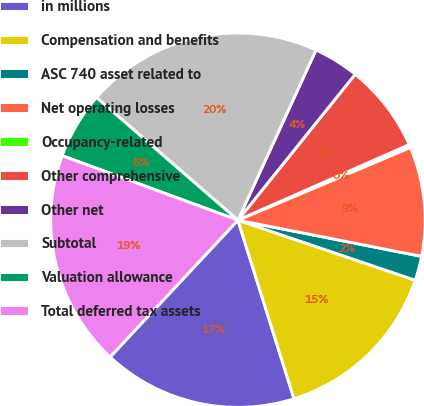Convert chart. <chart><loc_0><loc_0><loc_500><loc_500><pie_chart><fcel>in millions<fcel>Compensation and benefits<fcel>ASC 740 asset related to<fcel>Net operating losses<fcel>Occupancy-related<fcel>Other comprehensive<fcel>Other net<fcel>Subtotal<fcel>Valuation allowance<fcel>Total deferred tax assets<nl><fcel>16.8%<fcel>14.96%<fcel>2.1%<fcel>9.45%<fcel>0.26%<fcel>7.61%<fcel>3.93%<fcel>20.48%<fcel>5.77%<fcel>18.64%<nl></chart> 